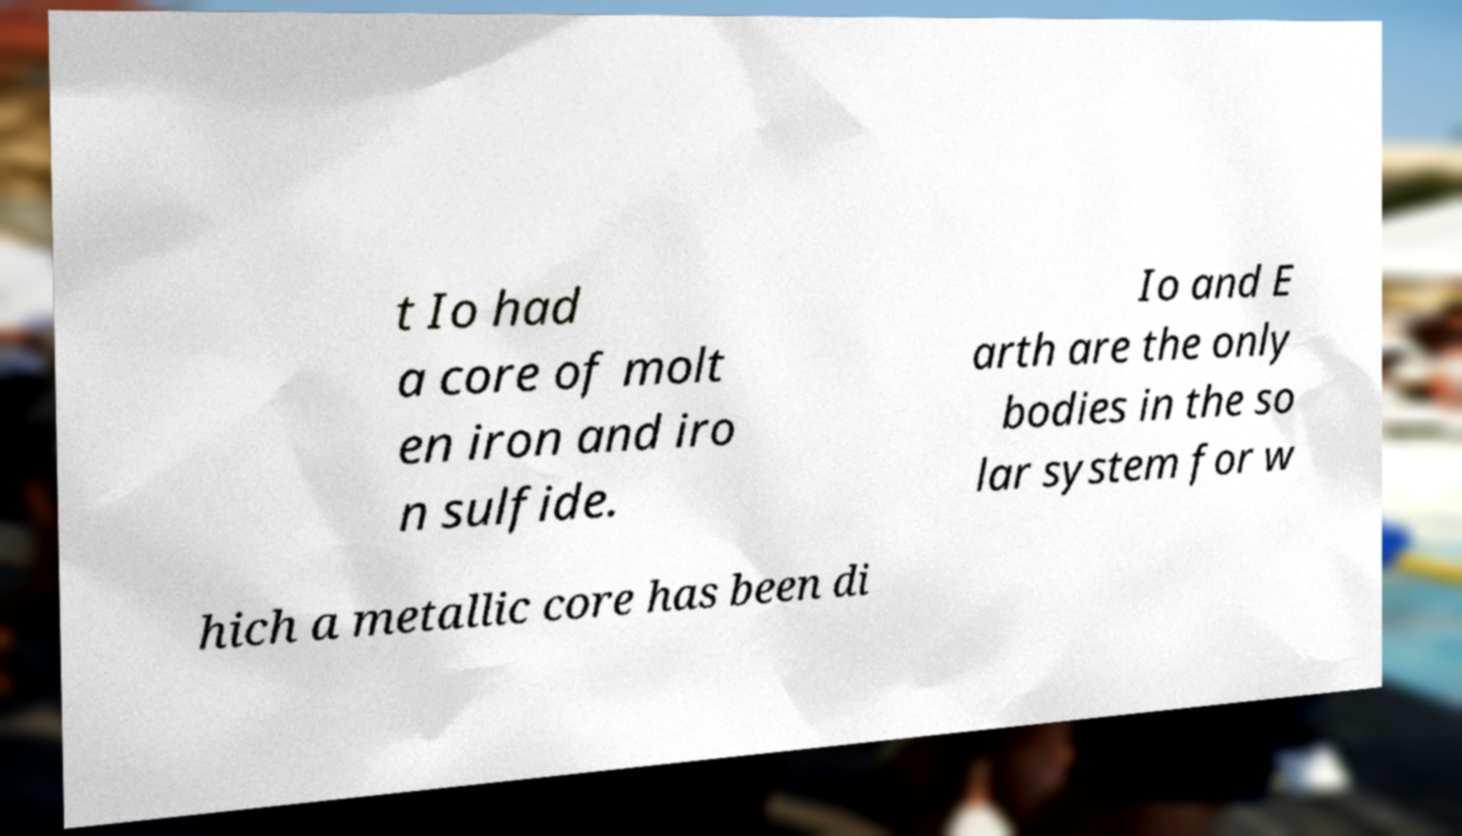Can you accurately transcribe the text from the provided image for me? t Io had a core of molt en iron and iro n sulfide. Io and E arth are the only bodies in the so lar system for w hich a metallic core has been di 